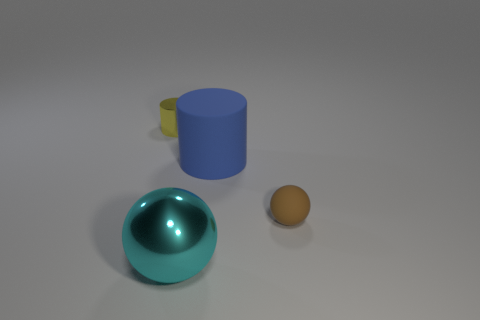Add 1 big blue cylinders. How many objects exist? 5 Add 1 large blue objects. How many large blue objects are left? 2 Add 4 large brown metallic things. How many large brown metallic things exist? 4 Subtract 0 blue cubes. How many objects are left? 4 Subtract all large cyan objects. Subtract all matte objects. How many objects are left? 1 